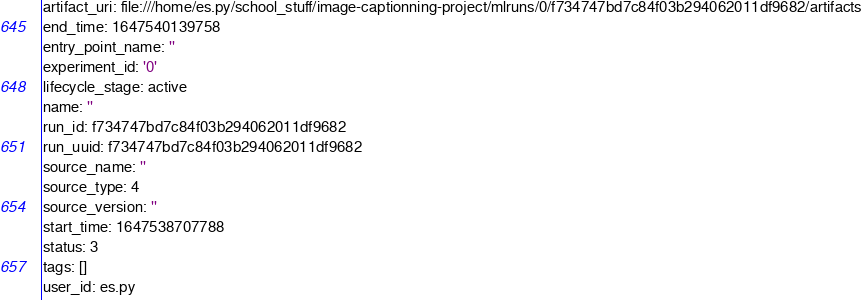Convert code to text. <code><loc_0><loc_0><loc_500><loc_500><_YAML_>artifact_uri: file:///home/es.py/school_stuff/image-captionning-project/mlruns/0/f734747bd7c84f03b294062011df9682/artifacts
end_time: 1647540139758
entry_point_name: ''
experiment_id: '0'
lifecycle_stage: active
name: ''
run_id: f734747bd7c84f03b294062011df9682
run_uuid: f734747bd7c84f03b294062011df9682
source_name: ''
source_type: 4
source_version: ''
start_time: 1647538707788
status: 3
tags: []
user_id: es.py
</code> 